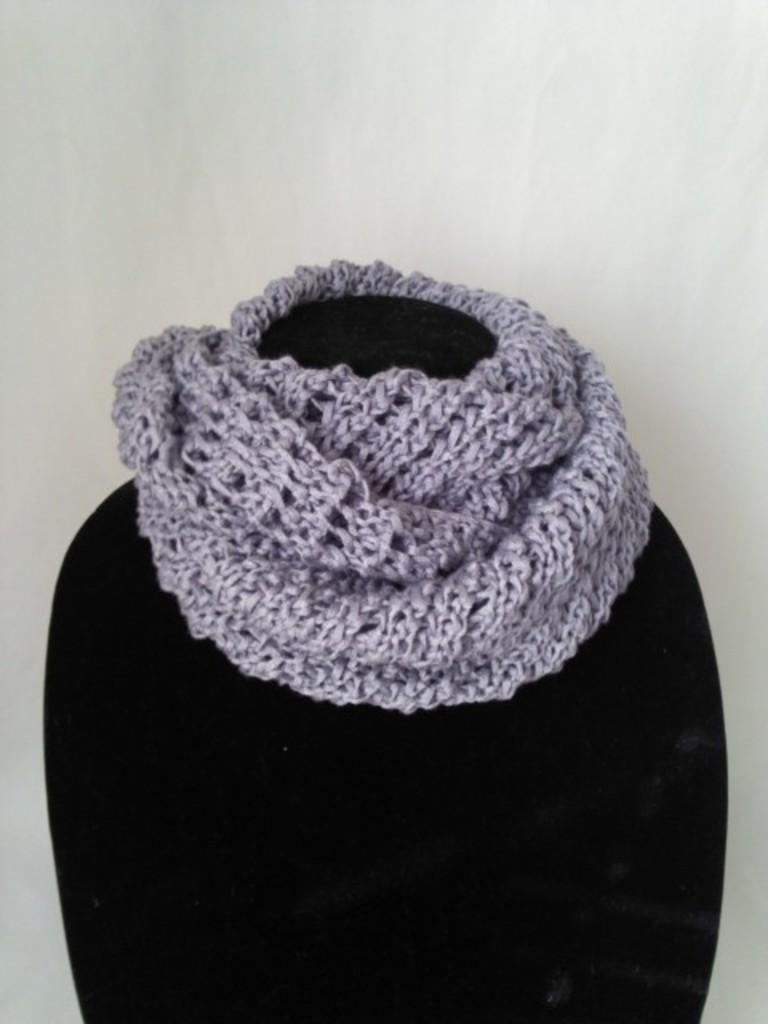What type of clothing item is featured in the image? There is a purple color woolen scarf in the image. Is the scarf being worn by anyone in the image? No, the scarf is on a mannequin. What color is the wall in the background of the image? The wall in the background of the image is white color. What type of wine is being served at the harbor in the image? There is no harbor or wine present in the image; it features a purple woolen scarf on a mannequin with a white wall in the background. 